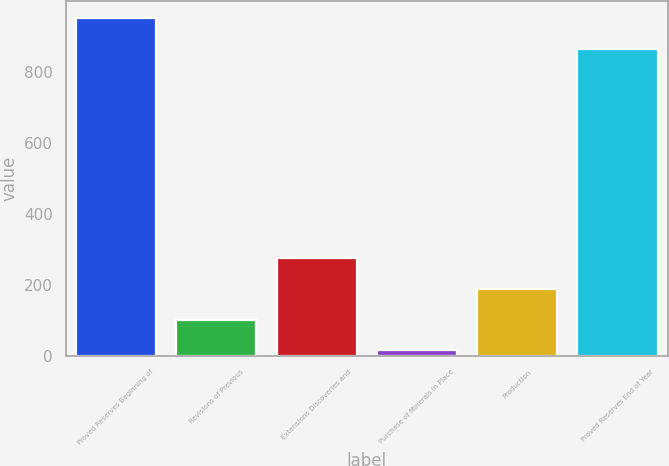Convert chart to OTSL. <chart><loc_0><loc_0><loc_500><loc_500><bar_chart><fcel>Proved Reserves Beginning of<fcel>Revisions of Previous<fcel>Extensions Discoveries and<fcel>Purchase of Minerals in Place<fcel>Production<fcel>Proved Reserves End of Year<nl><fcel>950.5<fcel>101.5<fcel>274.5<fcel>15<fcel>188<fcel>864<nl></chart> 